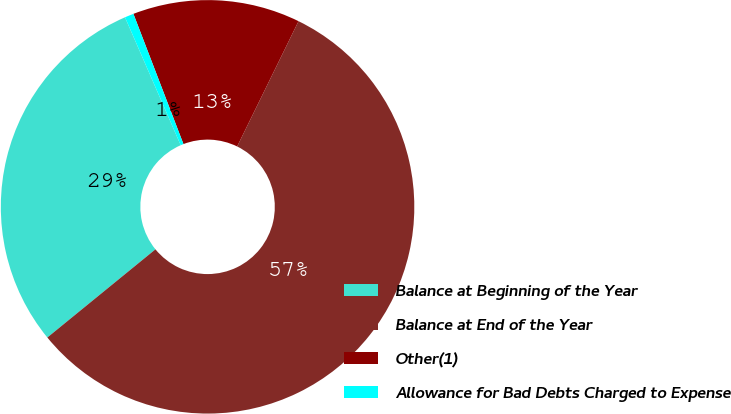Convert chart. <chart><loc_0><loc_0><loc_500><loc_500><pie_chart><fcel>Balance at Beginning of the Year<fcel>Balance at End of the Year<fcel>Other(1)<fcel>Allowance for Bad Debts Charged to Expense<nl><fcel>29.35%<fcel>56.86%<fcel>13.09%<fcel>0.7%<nl></chart> 